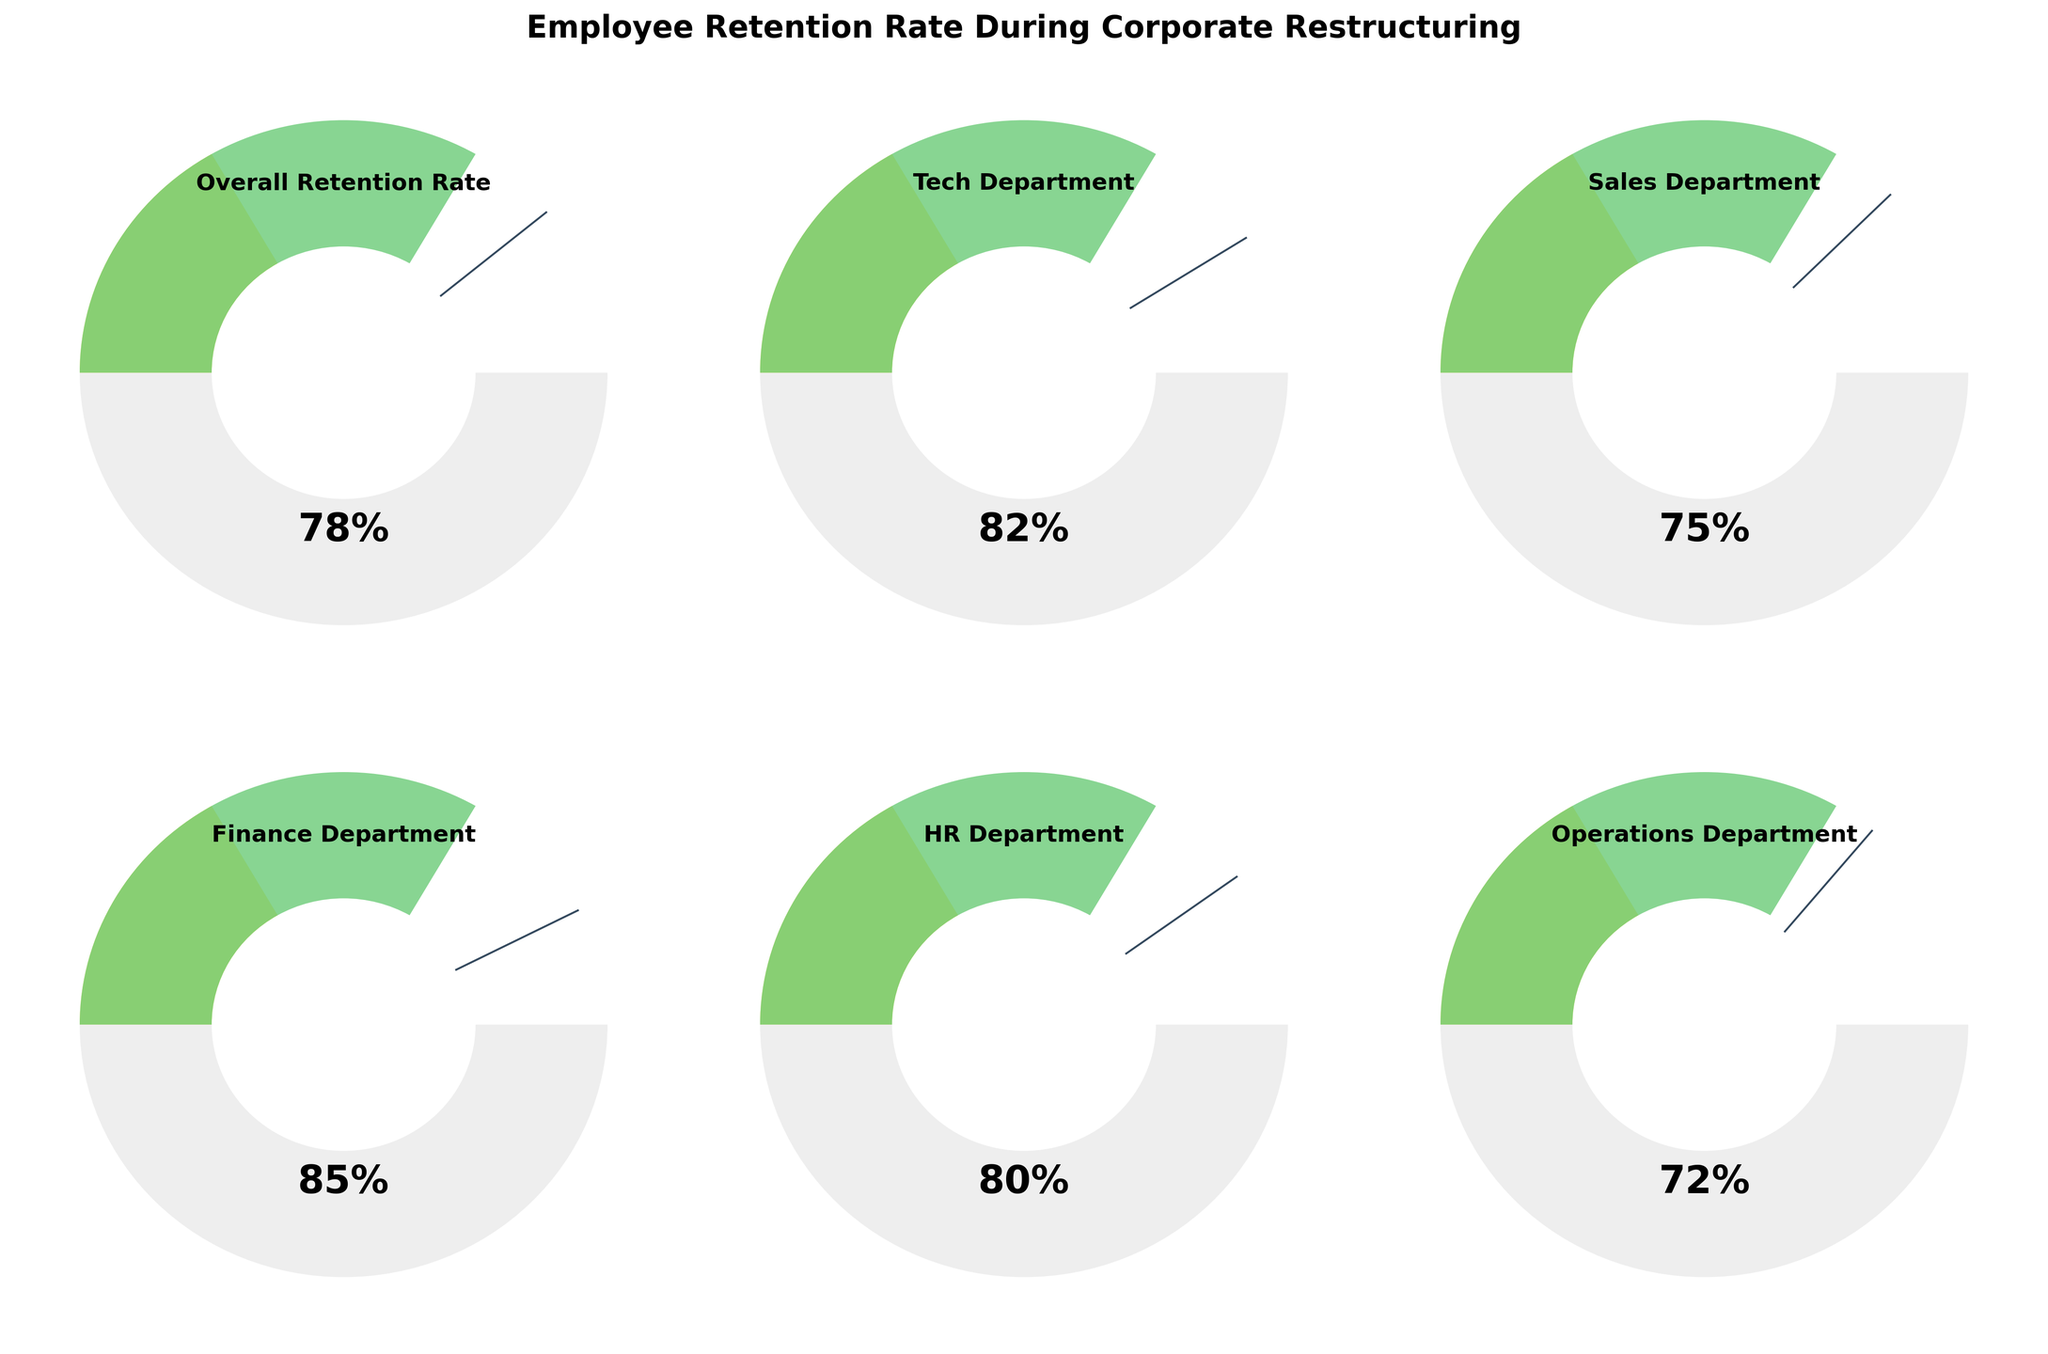What's the overall employee retention rate during corporate restructuring? The "Overall Retention Rate" gauge chart displays a value of 78%, which is easily seen in the center of the gauge.
Answer: 78% Which department has the highest employee retention rate? The finance department's gauge shows a retention rate of 85%, which is the highest value among all departments displayed.
Answer: Finance Department How does the retention rate of the Tech Department compare to the Sales Department? The Tech Department has a retention rate of 82%, while the Sales Department has 75%. To compare, 82% is greater than 75%.
Answer: Tech Department Calculate the average employee retention rate across all departments. Summing the retention rates of all departments: (82 + 75 + 85 + 80 + 72) = 394. Dividing by the number of departments (5) gives the average: 394 / 5 = 78.8%.
Answer: 78.8% What is the lowest employee retention rate among the departments? The Operations Department has the lowest retention rate, which is shown to be 72% on its gauge.
Answer: Operations Department Can you identify the range of retention rates across departments? The retention rates from the department gauges range from the lowest at 72% (Operations) to the highest at 85% (Finance). The range is the difference between these two values: 85% - 72% = 13%.
Answer: 13% Are there any departments with an employee retention rate exactly at or below 75%? The gauge for the Sales Department displays a retention rate of 75%, which meets the condition of being exactly at 75%. No other department is at or below this value.
Answer: Sales Department Which two departments have retention rates that differ by more than 10%? Comparing all pairs of departments:
- Finance (85%) vs. Operations (72%): difference = 13%
- Finance (85%) vs. Sales (75%): difference = 10%
- Others (Finance- Tech, Finance-HR, Operations-Tech, Operations-Sales, Operations-HR, Tech-Sales, Tech-HR, Sales-HR) all have differences less than or equal to 10%.
Thus, Finance and Operations have a retention rate difference of more than 10%.
Answer: Finance Department and Operations Department 